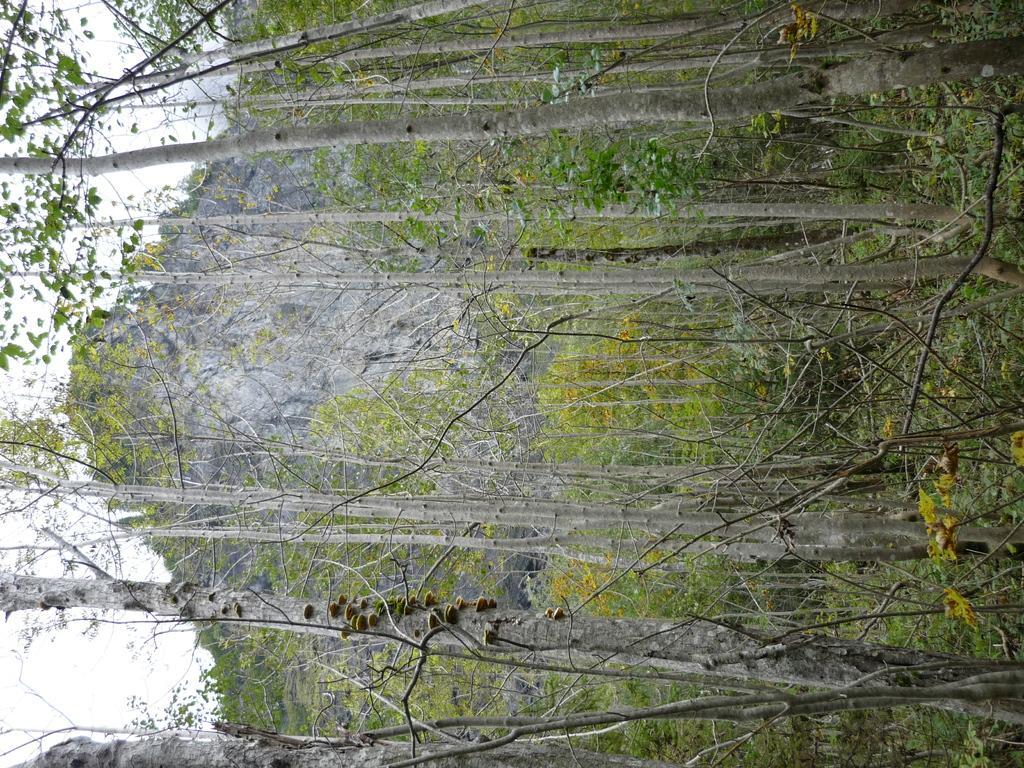In one or two sentences, can you explain what this image depicts? In this image we can see few trees, mountain and the sky in the background. 